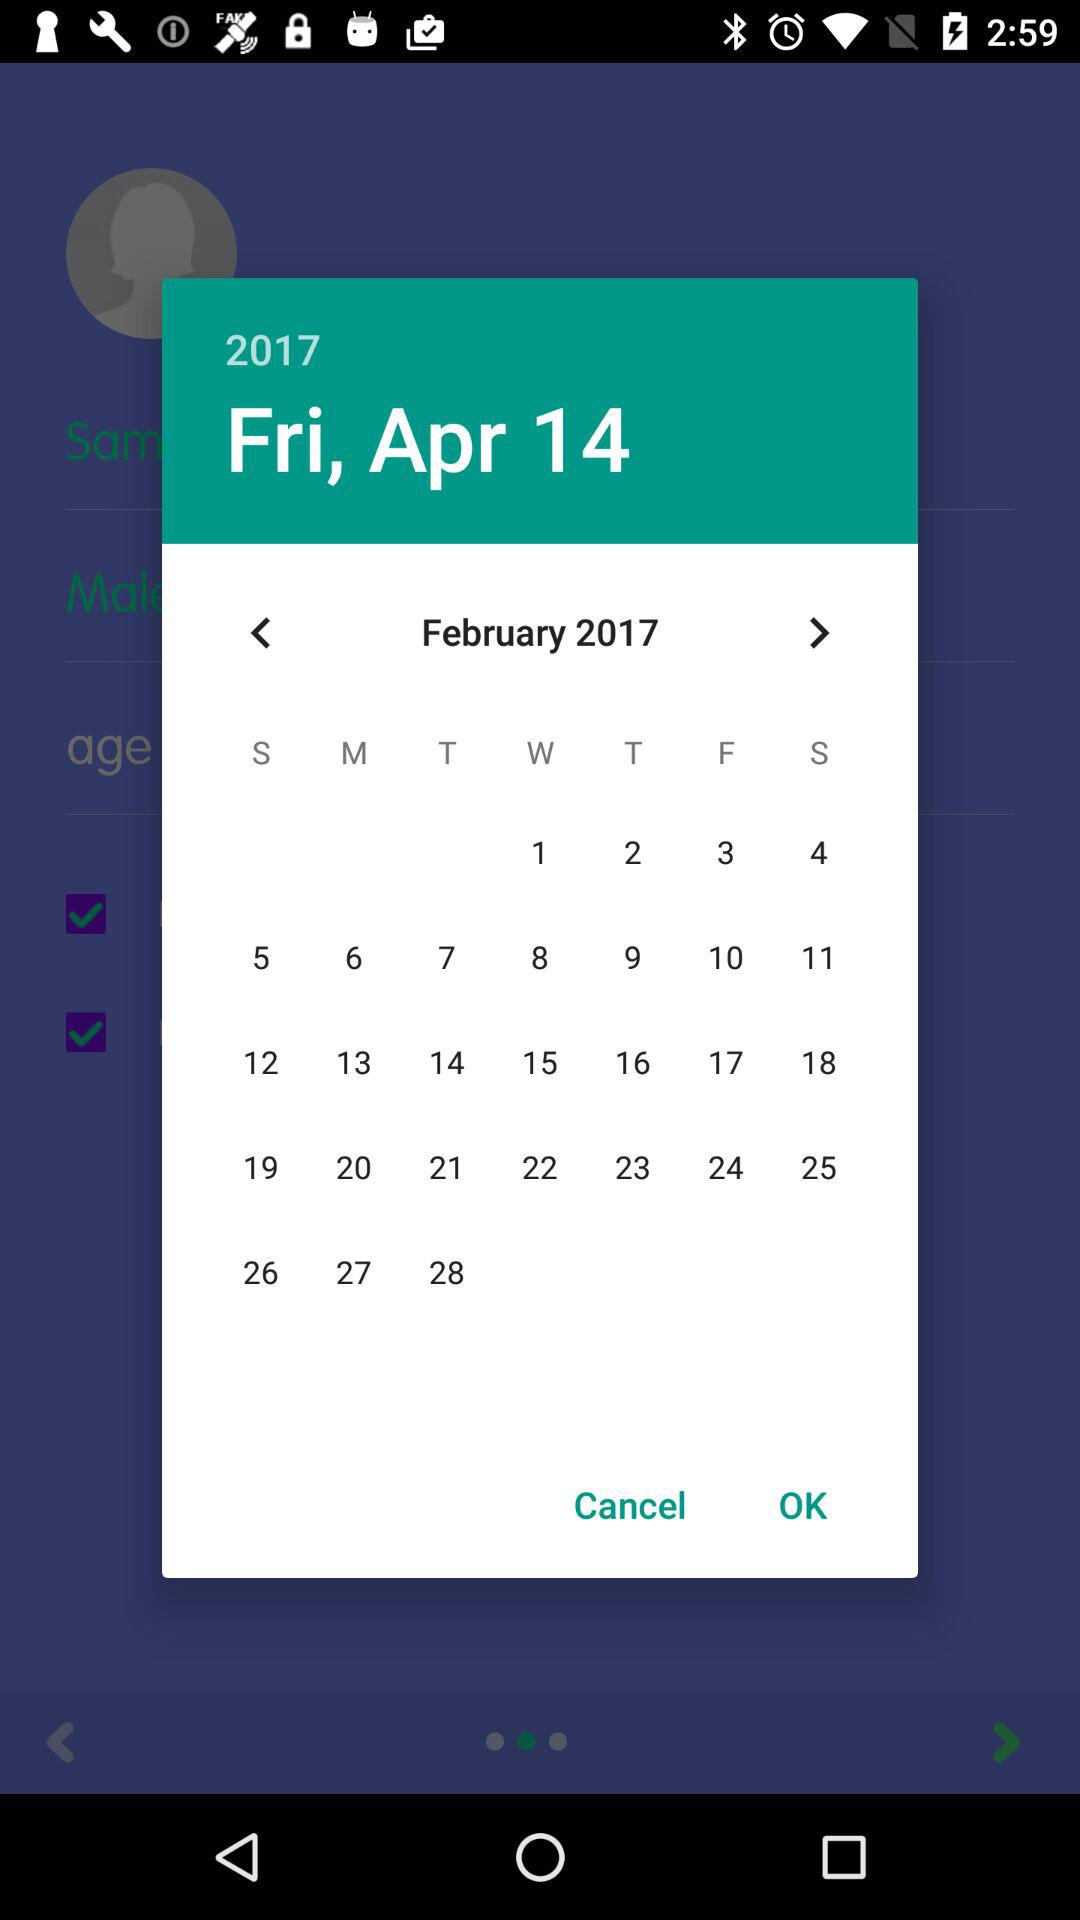Which is the year? The year is 2017. 